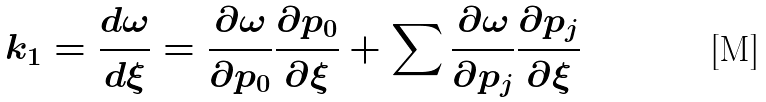Convert formula to latex. <formula><loc_0><loc_0><loc_500><loc_500>k _ { 1 } = \frac { d \omega } { d \xi } = \frac { \partial \omega } { \partial p _ { 0 } } \frac { \partial p _ { 0 } } { \partial \xi } + \sum \frac { \partial \omega } { \partial p _ { j } } \frac { \partial p _ { j } } { \partial \xi }</formula> 